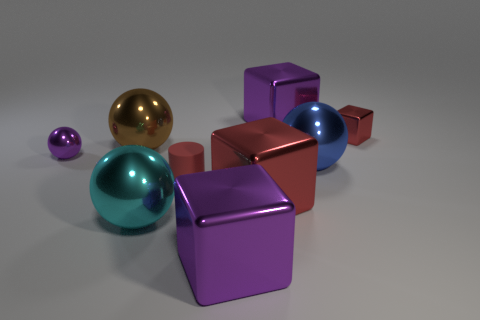Is the size of the brown metal object the same as the cylinder?
Provide a succinct answer. No. There is a purple object in front of the tiny purple ball behind the large red metal thing; how big is it?
Ensure brevity in your answer.  Large. What is the size of the metal ball that is both in front of the purple metal sphere and behind the tiny matte thing?
Your answer should be compact. Large. What number of red matte objects are the same size as the cyan shiny ball?
Your response must be concise. 0. What number of metallic objects are either blue balls or tiny red cubes?
Give a very brief answer. 2. There is another block that is the same color as the small metallic block; what size is it?
Your answer should be compact. Large. There is a red cube that is to the right of the purple thing on the right side of the big red metal block; what is its material?
Provide a succinct answer. Metal. How many objects are purple cubes or purple blocks that are in front of the large brown object?
Your answer should be very brief. 2. What size is the brown ball that is made of the same material as the large cyan ball?
Keep it short and to the point. Large. How many green objects are matte things or spheres?
Provide a short and direct response. 0. 